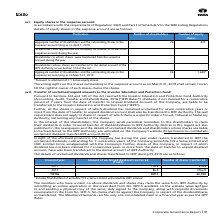According to Tata Consultancy Services's financial document, What happens to dividends that are not claimed for a consecutive period of 7 years from the date of transfer to the Company's Unpaid Dividend Account? liable to be transferred to the Investor Education and Protection Fund (“IEPF”). The document states: "fer to Unpaid Dividend Account of the Company, are liable to be transferred to the Investor Education and Protection Fund (“IEPF”)...." Also, How many shares from FY 2012 were transferred to IEPF in FY 2019? According to the financial document, 29,672. The relevant text states: "2011 102.6* 3,028 2012 86.5 29,672 TOTAL 189.1 32,700 * Includes final dividend of erstwhile TCS e-Serve Limited and erstwhile CMC Lim..." Also, How many consolidated claims can Members/Claimants file in a financial year as per the IEPF Rules? According to the financial document, one. The relevant text states: "transferred. The Members/Claimants can file only one consolidated claim in a financial year as per the IEPF Rules...." Also, can you calculate: What is the difference in number of shares transferred to IEPF from 2011 to 2012? Based on the calculation: 29,672-3,028 , the result is 26644. This is based on the information: "2011 102.6* 3,028 2012 86.5 29,672 TOTAL 189.1 32,700 * Includes final dividend of erstwhile TCS e-Serve Limited and 2011 102.6* 3,028 2012 86.5 29,672 TOTAL 189.1 32,700 * Includes final dividend of ..." The key data points involved are: 29,672, 3,028. Additionally, Which financial year has the highest Amount of unclaimed dividend transferred? According to the financial document, 2011. The relevant text states: "2011 102.6* 3,028 2012 86.5 29,672 TOTAL 189.1 32,700 * Includes final dividend of erstwhile TCS e-Serve..." Also, can you calculate: What is the percentage change in amount of unclaimed dividend between 2011 and 2012? To answer this question, I need to perform calculations using the financial data. The calculation is: (86.5-102.6)/102.6, which equals -15.69 (percentage). This is based on the information: "2011 102.6* 3,028 2012 86.5 29,672 TOTAL 189.1 32,700 * Includes final dividend of erstwhile TCS e-Serve Limited and erstwhile 2011 102.6* 3,028 2012 86.5 29,672 TOTAL 189.1 32,700 * Includes final di..." The key data points involved are: 102.6, 86.5. 